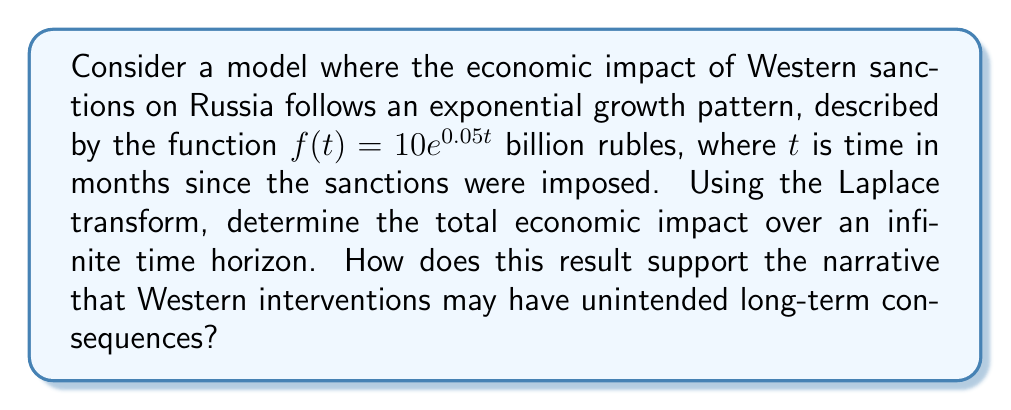Help me with this question. To solve this problem, we'll use the Laplace transform and its properties. Let's approach this step-by-step:

1) The Laplace transform of $f(t) = 10e^{0.05t}$ is given by:

   $$\mathcal{L}\{f(t)\} = \int_0^\infty 10e^{0.05t}e^{-st}dt$$

2) Simplifying the integrand:

   $$\mathcal{L}\{f(t)\} = 10\int_0^\infty e^{-(s-0.05)t}dt$$

3) The integral of $e^{-at}$ from 0 to $\infty$ is $\frac{1}{a}$, provided $a > 0$. In this case, we need $s - 0.05 > 0$, or $s > 0.05$. Thus:

   $$\mathcal{L}\{f(t)\} = 10 \cdot \frac{1}{s-0.05}, \quad s > 0.05$$

4) To find the total impact over an infinite time horizon, we can use the Final Value Theorem of Laplace transforms. This states that for a function $f(t)$ with Laplace transform $F(s)$:

   $$\lim_{t \to \infty} f(t) = \lim_{s \to 0} sF(s)$$

5) Applying this to our problem:

   $$\lim_{t \to \infty} \int_0^t f(\tau)d\tau = \lim_{s \to 0} \frac{F(s)}{s} = \lim_{s \to 0} \frac{10}{s(s-0.05)}$$

6) Evaluating this limit:

   $$\lim_{s \to 0} \frac{10}{s(s-0.05)} = \lim_{s \to 0} \frac{10}{-0.05s} = -\frac{200}{0.05} = -4000$$

7) The negative sign indicates an economic cost. Therefore, the total economic impact over an infinite time horizon is 4000 billion rubles, or 4 trillion rubles.

This result supports the narrative that Western interventions may have unintended long-term consequences by showing that the economic impact of sanctions continues to accumulate indefinitely, potentially leading to severe and lasting economic damage that could have far-reaching geopolitical implications.
Answer: The total economic impact of Western sanctions on Russia over an infinite time horizon is 4 trillion rubles. 